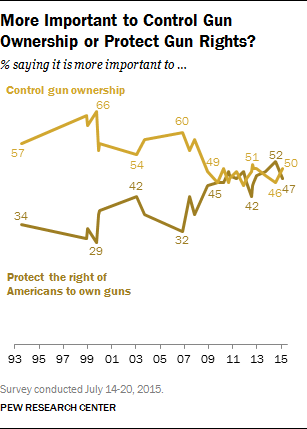Can you tell me more about the context of this image? This image is a line graph that compares the public opinion on whether it's more important to control gun ownership or protect the right of Americans to own guns over a span of years from 1993 to 2015. Conducted by the Pew Research Center, this survey reflects the shifts in societal attitudes on this politically charged issue. Such data is crucial for lawmakers, interest groups, and the general public to understand the evolving landscape of gun rights and gun control advocacy. 